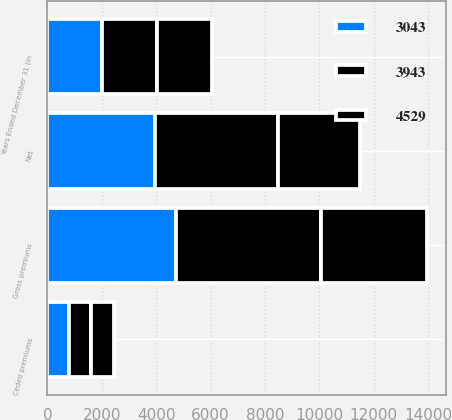Convert chart to OTSL. <chart><loc_0><loc_0><loc_500><loc_500><stacked_bar_chart><ecel><fcel>Years Ended December 31 (in<fcel>Gross premiums<fcel>Ceded premiums<fcel>Net<nl><fcel>4529<fcel>2018<fcel>3893<fcel>850<fcel>3043<nl><fcel>3943<fcel>2017<fcel>5338<fcel>809<fcel>4529<nl><fcel>3043<fcel>2016<fcel>4732<fcel>789<fcel>3943<nl></chart> 